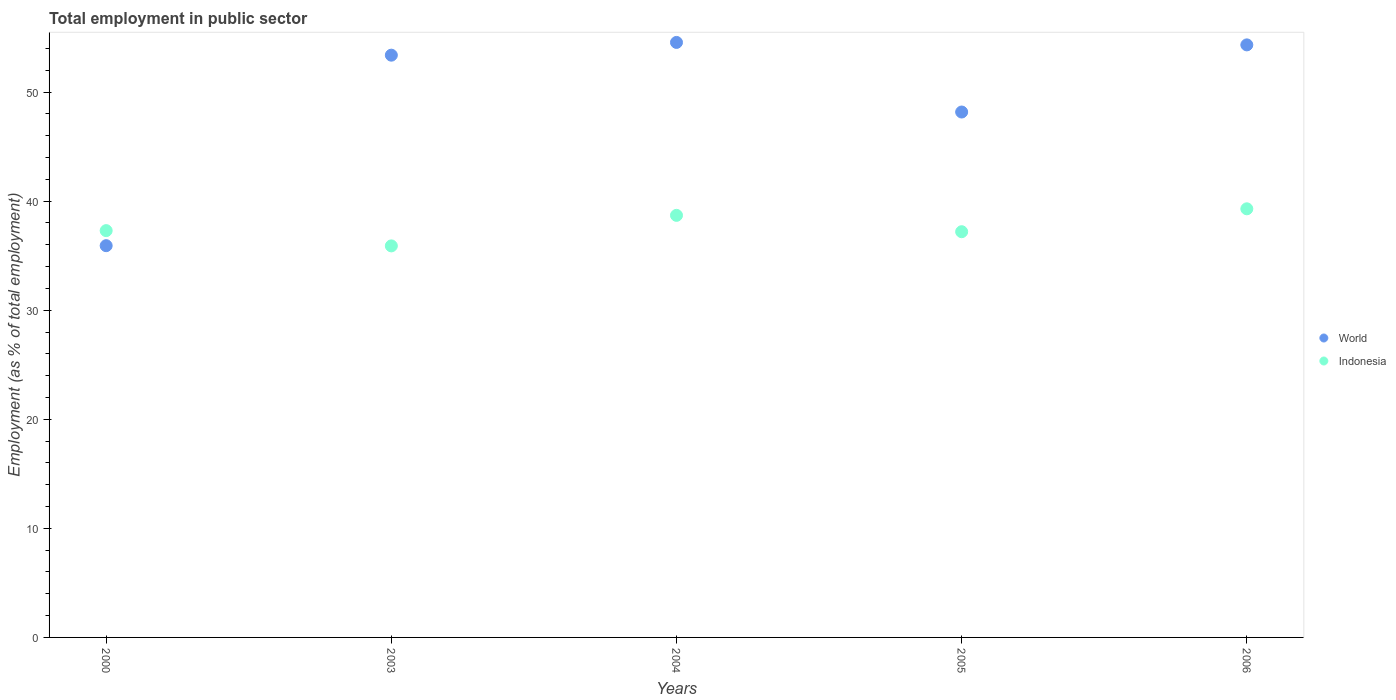What is the employment in public sector in World in 2003?
Ensure brevity in your answer.  53.39. Across all years, what is the maximum employment in public sector in World?
Offer a terse response. 54.56. Across all years, what is the minimum employment in public sector in Indonesia?
Keep it short and to the point. 35.9. In which year was the employment in public sector in World maximum?
Offer a terse response. 2004. What is the total employment in public sector in World in the graph?
Keep it short and to the point. 246.37. What is the difference between the employment in public sector in Indonesia in 2000 and that in 2004?
Give a very brief answer. -1.4. What is the difference between the employment in public sector in Indonesia in 2004 and the employment in public sector in World in 2003?
Your answer should be very brief. -14.69. What is the average employment in public sector in Indonesia per year?
Your answer should be compact. 37.68. In the year 2003, what is the difference between the employment in public sector in World and employment in public sector in Indonesia?
Offer a terse response. 17.49. What is the ratio of the employment in public sector in World in 2003 to that in 2004?
Ensure brevity in your answer.  0.98. Is the employment in public sector in Indonesia in 2003 less than that in 2005?
Your response must be concise. Yes. What is the difference between the highest and the second highest employment in public sector in World?
Provide a short and direct response. 0.23. What is the difference between the highest and the lowest employment in public sector in World?
Your answer should be compact. 18.64. In how many years, is the employment in public sector in Indonesia greater than the average employment in public sector in Indonesia taken over all years?
Your response must be concise. 2. Does the employment in public sector in World monotonically increase over the years?
Provide a short and direct response. No. Are the values on the major ticks of Y-axis written in scientific E-notation?
Your response must be concise. No. Does the graph contain grids?
Keep it short and to the point. No. How many legend labels are there?
Provide a succinct answer. 2. What is the title of the graph?
Your answer should be very brief. Total employment in public sector. What is the label or title of the Y-axis?
Ensure brevity in your answer.  Employment (as % of total employment). What is the Employment (as % of total employment) of World in 2000?
Your response must be concise. 35.92. What is the Employment (as % of total employment) of Indonesia in 2000?
Your answer should be very brief. 37.3. What is the Employment (as % of total employment) of World in 2003?
Your answer should be compact. 53.39. What is the Employment (as % of total employment) of Indonesia in 2003?
Keep it short and to the point. 35.9. What is the Employment (as % of total employment) of World in 2004?
Provide a short and direct response. 54.56. What is the Employment (as % of total employment) in Indonesia in 2004?
Offer a very short reply. 38.7. What is the Employment (as % of total employment) in World in 2005?
Your answer should be very brief. 48.17. What is the Employment (as % of total employment) in Indonesia in 2005?
Provide a succinct answer. 37.2. What is the Employment (as % of total employment) in World in 2006?
Make the answer very short. 54.33. What is the Employment (as % of total employment) in Indonesia in 2006?
Your answer should be very brief. 39.3. Across all years, what is the maximum Employment (as % of total employment) in World?
Ensure brevity in your answer.  54.56. Across all years, what is the maximum Employment (as % of total employment) in Indonesia?
Give a very brief answer. 39.3. Across all years, what is the minimum Employment (as % of total employment) in World?
Offer a terse response. 35.92. Across all years, what is the minimum Employment (as % of total employment) of Indonesia?
Your answer should be very brief. 35.9. What is the total Employment (as % of total employment) in World in the graph?
Provide a short and direct response. 246.37. What is the total Employment (as % of total employment) in Indonesia in the graph?
Offer a very short reply. 188.4. What is the difference between the Employment (as % of total employment) of World in 2000 and that in 2003?
Offer a terse response. -17.47. What is the difference between the Employment (as % of total employment) of World in 2000 and that in 2004?
Offer a terse response. -18.64. What is the difference between the Employment (as % of total employment) of World in 2000 and that in 2005?
Give a very brief answer. -12.26. What is the difference between the Employment (as % of total employment) of World in 2000 and that in 2006?
Offer a terse response. -18.41. What is the difference between the Employment (as % of total employment) of Indonesia in 2000 and that in 2006?
Offer a very short reply. -2. What is the difference between the Employment (as % of total employment) of World in 2003 and that in 2004?
Keep it short and to the point. -1.17. What is the difference between the Employment (as % of total employment) of Indonesia in 2003 and that in 2004?
Offer a very short reply. -2.8. What is the difference between the Employment (as % of total employment) of World in 2003 and that in 2005?
Your response must be concise. 5.21. What is the difference between the Employment (as % of total employment) of World in 2003 and that in 2006?
Offer a very short reply. -0.94. What is the difference between the Employment (as % of total employment) in World in 2004 and that in 2005?
Make the answer very short. 6.38. What is the difference between the Employment (as % of total employment) of World in 2004 and that in 2006?
Keep it short and to the point. 0.23. What is the difference between the Employment (as % of total employment) in World in 2005 and that in 2006?
Ensure brevity in your answer.  -6.16. What is the difference between the Employment (as % of total employment) of Indonesia in 2005 and that in 2006?
Give a very brief answer. -2.1. What is the difference between the Employment (as % of total employment) of World in 2000 and the Employment (as % of total employment) of Indonesia in 2003?
Offer a terse response. 0.02. What is the difference between the Employment (as % of total employment) in World in 2000 and the Employment (as % of total employment) in Indonesia in 2004?
Ensure brevity in your answer.  -2.78. What is the difference between the Employment (as % of total employment) of World in 2000 and the Employment (as % of total employment) of Indonesia in 2005?
Keep it short and to the point. -1.28. What is the difference between the Employment (as % of total employment) of World in 2000 and the Employment (as % of total employment) of Indonesia in 2006?
Give a very brief answer. -3.38. What is the difference between the Employment (as % of total employment) of World in 2003 and the Employment (as % of total employment) of Indonesia in 2004?
Offer a very short reply. 14.69. What is the difference between the Employment (as % of total employment) in World in 2003 and the Employment (as % of total employment) in Indonesia in 2005?
Your response must be concise. 16.19. What is the difference between the Employment (as % of total employment) in World in 2003 and the Employment (as % of total employment) in Indonesia in 2006?
Keep it short and to the point. 14.09. What is the difference between the Employment (as % of total employment) in World in 2004 and the Employment (as % of total employment) in Indonesia in 2005?
Keep it short and to the point. 17.36. What is the difference between the Employment (as % of total employment) of World in 2004 and the Employment (as % of total employment) of Indonesia in 2006?
Keep it short and to the point. 15.26. What is the difference between the Employment (as % of total employment) of World in 2005 and the Employment (as % of total employment) of Indonesia in 2006?
Provide a short and direct response. 8.87. What is the average Employment (as % of total employment) of World per year?
Your answer should be compact. 49.27. What is the average Employment (as % of total employment) in Indonesia per year?
Keep it short and to the point. 37.68. In the year 2000, what is the difference between the Employment (as % of total employment) in World and Employment (as % of total employment) in Indonesia?
Your answer should be very brief. -1.38. In the year 2003, what is the difference between the Employment (as % of total employment) in World and Employment (as % of total employment) in Indonesia?
Your response must be concise. 17.49. In the year 2004, what is the difference between the Employment (as % of total employment) in World and Employment (as % of total employment) in Indonesia?
Your response must be concise. 15.86. In the year 2005, what is the difference between the Employment (as % of total employment) of World and Employment (as % of total employment) of Indonesia?
Offer a very short reply. 10.97. In the year 2006, what is the difference between the Employment (as % of total employment) in World and Employment (as % of total employment) in Indonesia?
Give a very brief answer. 15.03. What is the ratio of the Employment (as % of total employment) in World in 2000 to that in 2003?
Your response must be concise. 0.67. What is the ratio of the Employment (as % of total employment) in Indonesia in 2000 to that in 2003?
Give a very brief answer. 1.04. What is the ratio of the Employment (as % of total employment) in World in 2000 to that in 2004?
Provide a succinct answer. 0.66. What is the ratio of the Employment (as % of total employment) in Indonesia in 2000 to that in 2004?
Provide a short and direct response. 0.96. What is the ratio of the Employment (as % of total employment) of World in 2000 to that in 2005?
Keep it short and to the point. 0.75. What is the ratio of the Employment (as % of total employment) in World in 2000 to that in 2006?
Provide a short and direct response. 0.66. What is the ratio of the Employment (as % of total employment) in Indonesia in 2000 to that in 2006?
Give a very brief answer. 0.95. What is the ratio of the Employment (as % of total employment) of World in 2003 to that in 2004?
Ensure brevity in your answer.  0.98. What is the ratio of the Employment (as % of total employment) in Indonesia in 2003 to that in 2004?
Offer a terse response. 0.93. What is the ratio of the Employment (as % of total employment) in World in 2003 to that in 2005?
Give a very brief answer. 1.11. What is the ratio of the Employment (as % of total employment) in Indonesia in 2003 to that in 2005?
Provide a short and direct response. 0.97. What is the ratio of the Employment (as % of total employment) of World in 2003 to that in 2006?
Provide a succinct answer. 0.98. What is the ratio of the Employment (as % of total employment) of Indonesia in 2003 to that in 2006?
Your answer should be compact. 0.91. What is the ratio of the Employment (as % of total employment) of World in 2004 to that in 2005?
Give a very brief answer. 1.13. What is the ratio of the Employment (as % of total employment) in Indonesia in 2004 to that in 2005?
Your response must be concise. 1.04. What is the ratio of the Employment (as % of total employment) of World in 2004 to that in 2006?
Your answer should be compact. 1. What is the ratio of the Employment (as % of total employment) in Indonesia in 2004 to that in 2006?
Make the answer very short. 0.98. What is the ratio of the Employment (as % of total employment) in World in 2005 to that in 2006?
Make the answer very short. 0.89. What is the ratio of the Employment (as % of total employment) of Indonesia in 2005 to that in 2006?
Offer a terse response. 0.95. What is the difference between the highest and the second highest Employment (as % of total employment) in World?
Your response must be concise. 0.23. What is the difference between the highest and the second highest Employment (as % of total employment) of Indonesia?
Your answer should be very brief. 0.6. What is the difference between the highest and the lowest Employment (as % of total employment) of World?
Make the answer very short. 18.64. What is the difference between the highest and the lowest Employment (as % of total employment) in Indonesia?
Provide a short and direct response. 3.4. 